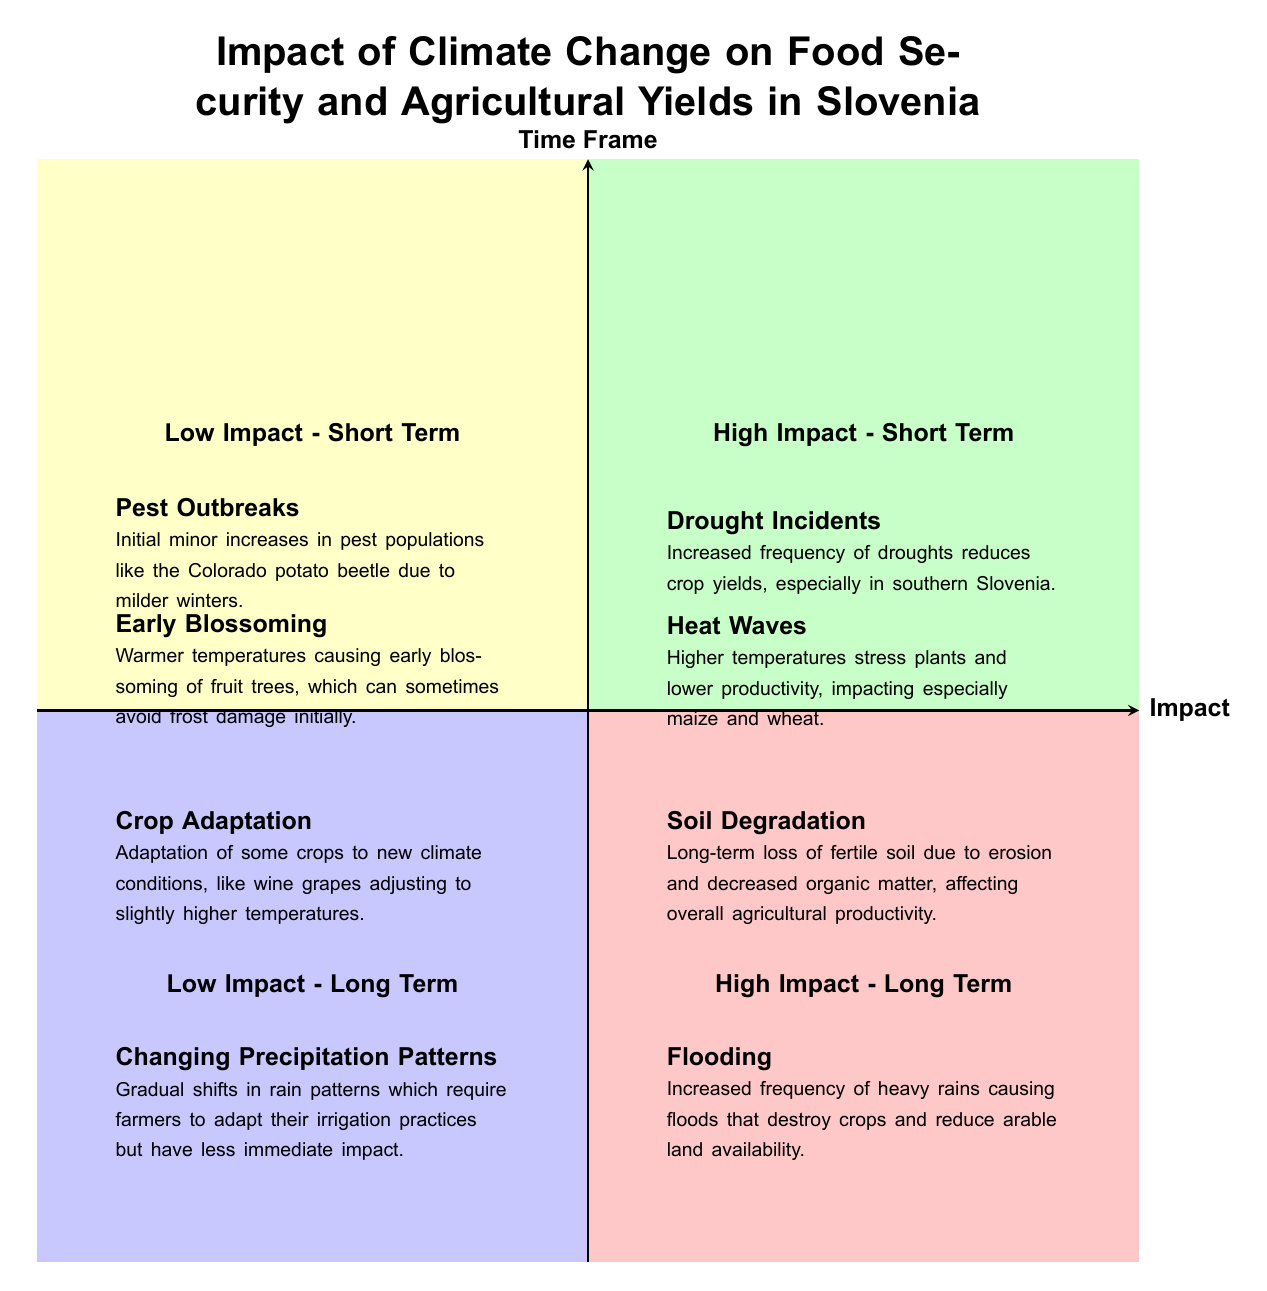What are the two items located in the "High Impact - Short Term" quadrant? The items listed in the "High Impact - Short Term" quadrant are "Drought Incidents" and "Heat Waves." They are both located in the upper right section of the diagram, which represents high impact events that occur in the short term.
Answer: Drought Incidents, Heat Waves How many items are there in the "Low Impact - Long Term" quadrant? In the "Low Impact - Long Term" quadrant, there are two items: "Crop Adaptation" and "Changing Precipitation Patterns." This quadrant is located in the lower left section of the diagram, indicating low impact events over a longer time frame.
Answer: 2 What type of impact is associated with flooding according to the diagram? Flooding is categorized as a "High Impact - Long Term" event based on its location in the upper right quadrant aligned with long-term impact and high severity.
Answer: High Impact - Long Term Are there any items listed in the "Low Impact - Short Term" quadrant that relate to early pest population changes? Yes, "Pest Outbreaks" is listed in the "Low Impact - Short Term" quadrant, indicating that it has an impact that is considered low in severity and occurs in the short term.
Answer: Yes Which quadrant features "Soil Degradation"? "Soil Degradation" is found in the "High Impact - Long Term" quadrant, indicating that it is a significant issue with long-term consequences for agricultural productivity in Slovenia.
Answer: High Impact - Long Term If a farmer adapts to changing precipitation patterns, which quadrant does this fall under, and how is it categorized? "Changing Precipitation Patterns" is in the "Low Impact - Long Term" quadrant, meaning that while it requires adaptation, its immediate impact is low and concerns long-term changes.
Answer: Low Impact - Long Term What is the key reason for the inclusion of "Heat Waves" in the short-term high impact quadrant? "Heat Waves" are included in the "High Impact - Short Term" quadrant because they cause immediate stress to crops, which negatively affects productivity quickly, particularly for essential crops like maize and wheat.
Answer: Stress to crops Which two items suggest agricultural adaptation in response to climate changes? The items suggesting agricultural adaptation are "Crop Adaptation" and "Early Blossoming." Both reflect how agriculture is responding to shifting climate conditions, but they are classified under different impacts and time frames in the quadrants.
Answer: Crop Adaptation, Early Blossoming 